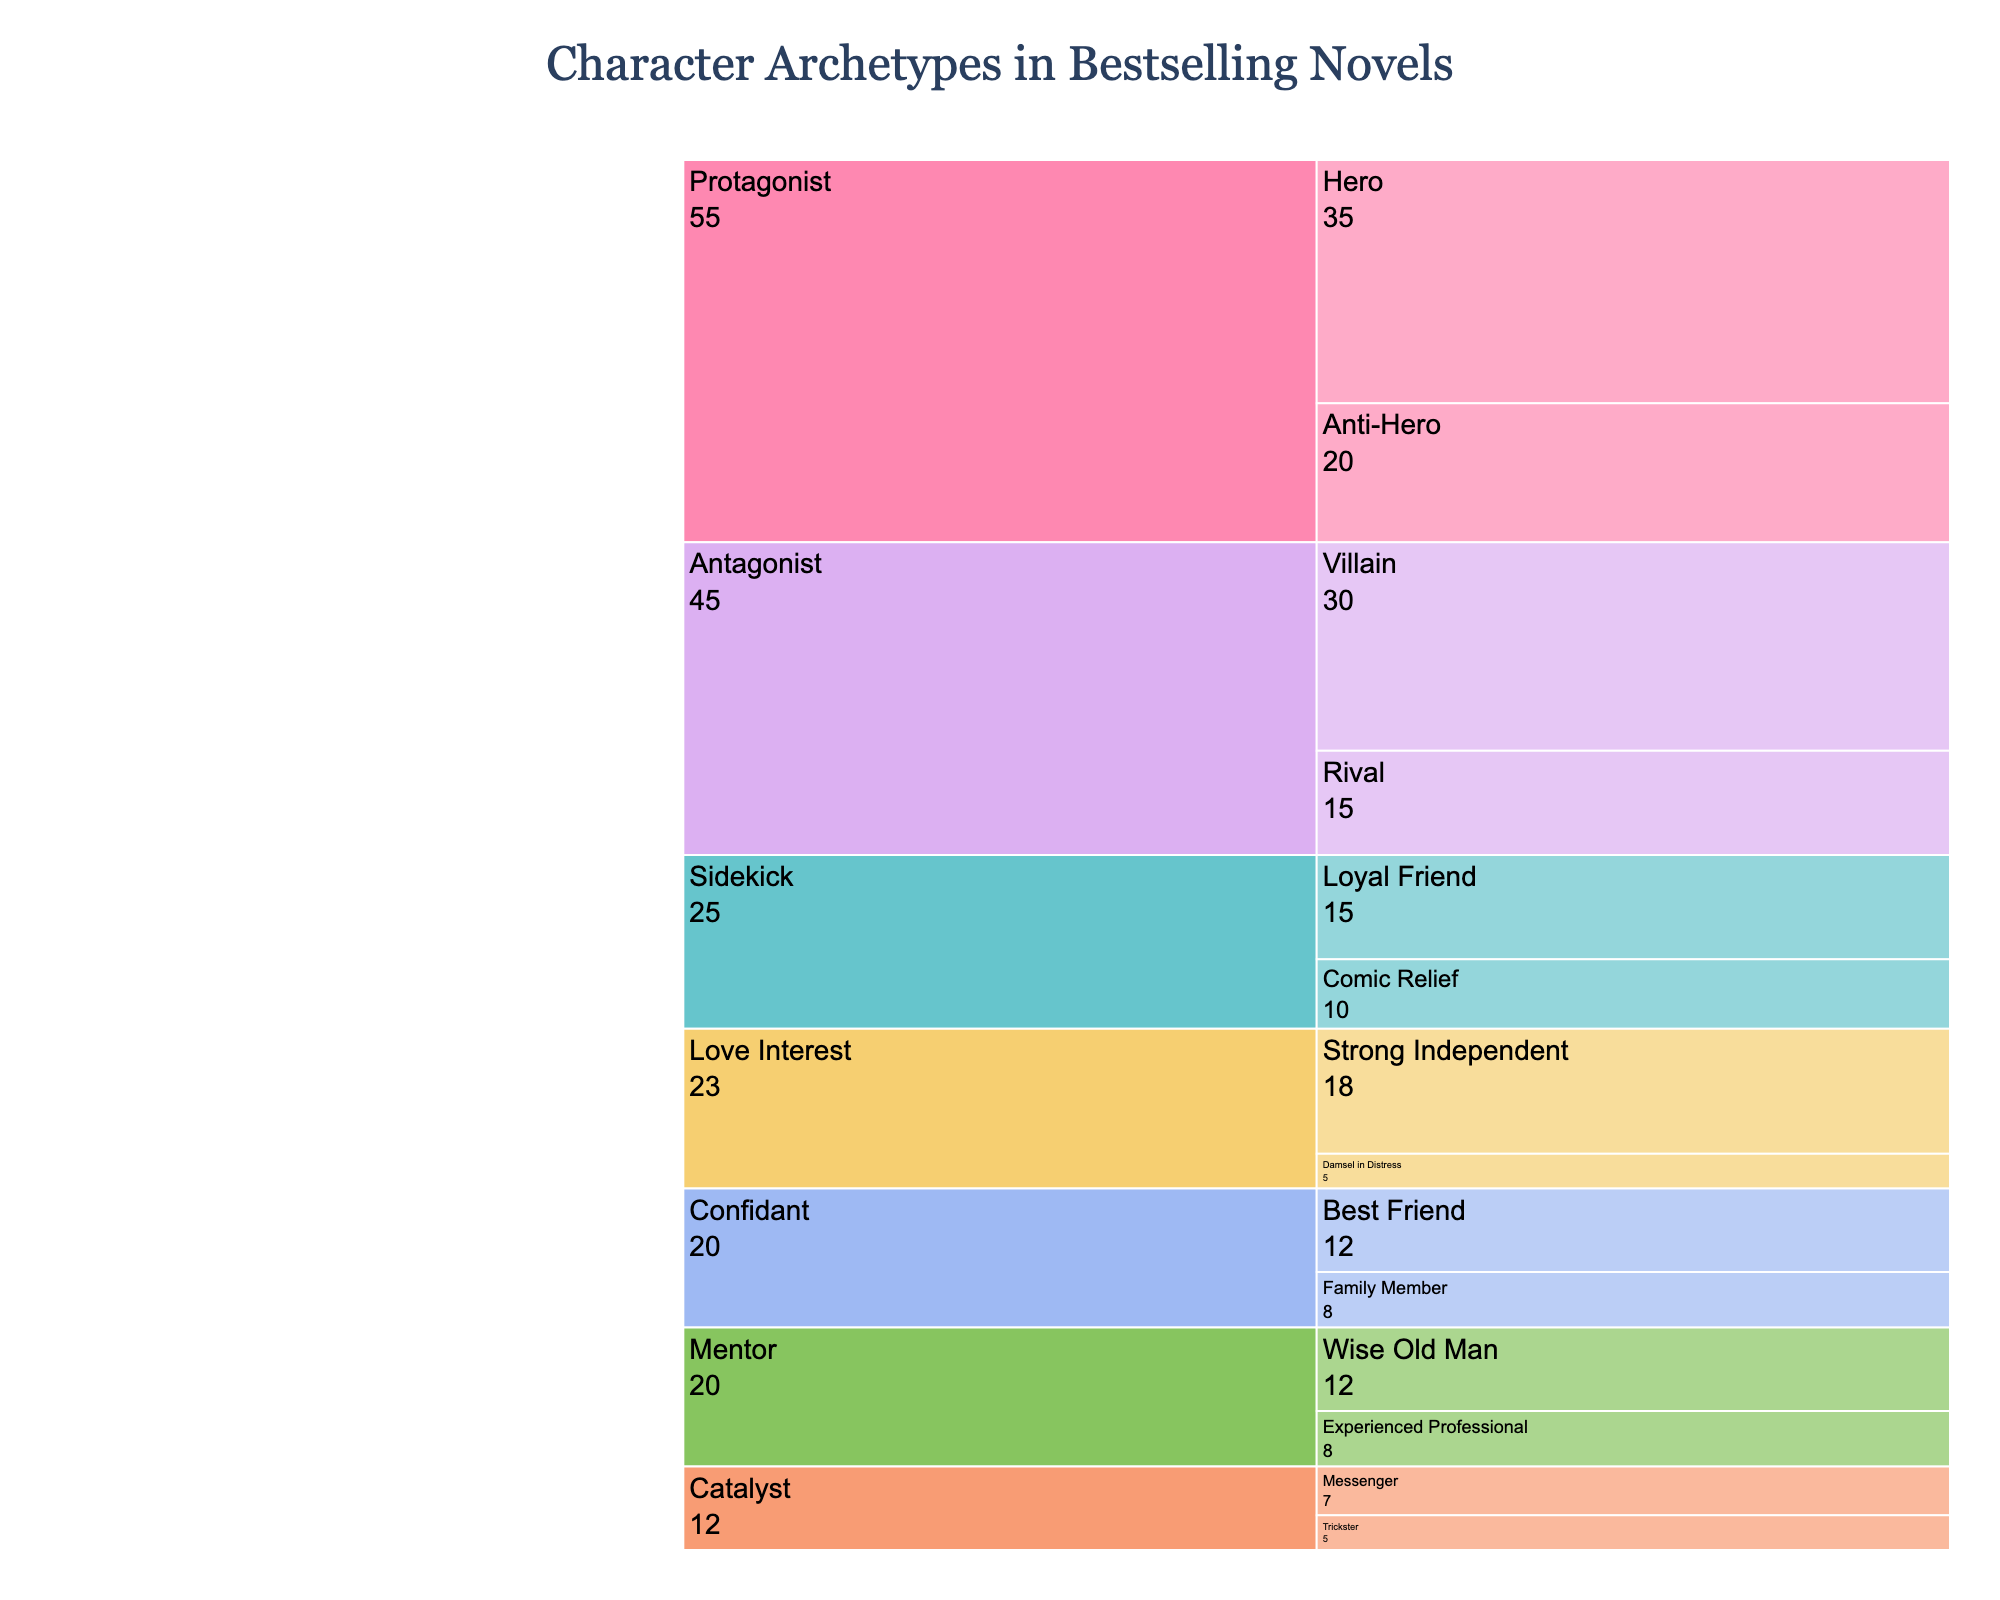What's the title of the figure? The title is located at the top of the figure and is a textual element that describes the data being visualized.
Answer: Character Archetypes in Bestselling Novels Which character archetype has the highest frequency? By looking at the lengths of the bars for each archetype, you can visually determine the one with the highest frequency. Protagonist has the longest bar.
Answer: Protagonist How many subtypes does the Mentor archetype have? Each archetype branches out into its respective subtypes. Counting the branches under Mentor shows two subtypes: Wise Old Man and Experienced Professional.
Answer: 2 What is the combined frequency of the Confidant and Sidekick archetypes? To get the combined frequency, add their individual total frequencies. Confidant (12 + 8) and Sidekick (10 + 15), thus: 20 + 25 = 45.
Answer: 45 Which is more common, the Hero subtype or the Villain subtype? By comparing the lengths of the bars for Hero and Villain subtypes, we can see which one is longer. Hero (35) is longer than Villain (30).
Answer: Hero What's the average frequency of Love Interest subtypes? Add the frequencies of subtypes under Love Interest (5 + 18) and divide by the number of subtypes (2). So, (5 + 18) / 2 = 11.5.
Answer: 11.5 Which character archetype has the fewest total subtypes? Count the subtypes under each main archetype. Love Interest and Catalyst both have only 2 subtypes each.
Answer: Love Interest, Catalyst Is the frequency of the Anti-Hero subtype greater than the combined frequency of the Catalyst subtypes? Compare frequency of Anti-Hero (20) with the combined frequency of Catalyst subtypes (7 + 5 = 12). 20 is greater than 12.
Answer: Yes By how much does the frequency of the Villain subtype exceed that of the Comic Relief subtype? Subtract the frequency of Comic Relief from that of Villain (30 - 10).
Answer: 20 